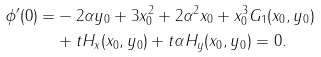Convert formula to latex. <formula><loc_0><loc_0><loc_500><loc_500>\phi ^ { \prime } ( 0 ) = & - 2 \alpha y _ { 0 } + 3 x _ { 0 } ^ { 2 } + 2 \alpha ^ { 2 } x _ { 0 } + x _ { 0 } ^ { 3 } G _ { 1 } ( x _ { 0 } , y _ { 0 } ) \\ & + t H _ { x } ( x _ { 0 } , y _ { 0 } ) + t \alpha H _ { y } ( x _ { 0 } , y _ { 0 } ) = 0 .</formula> 